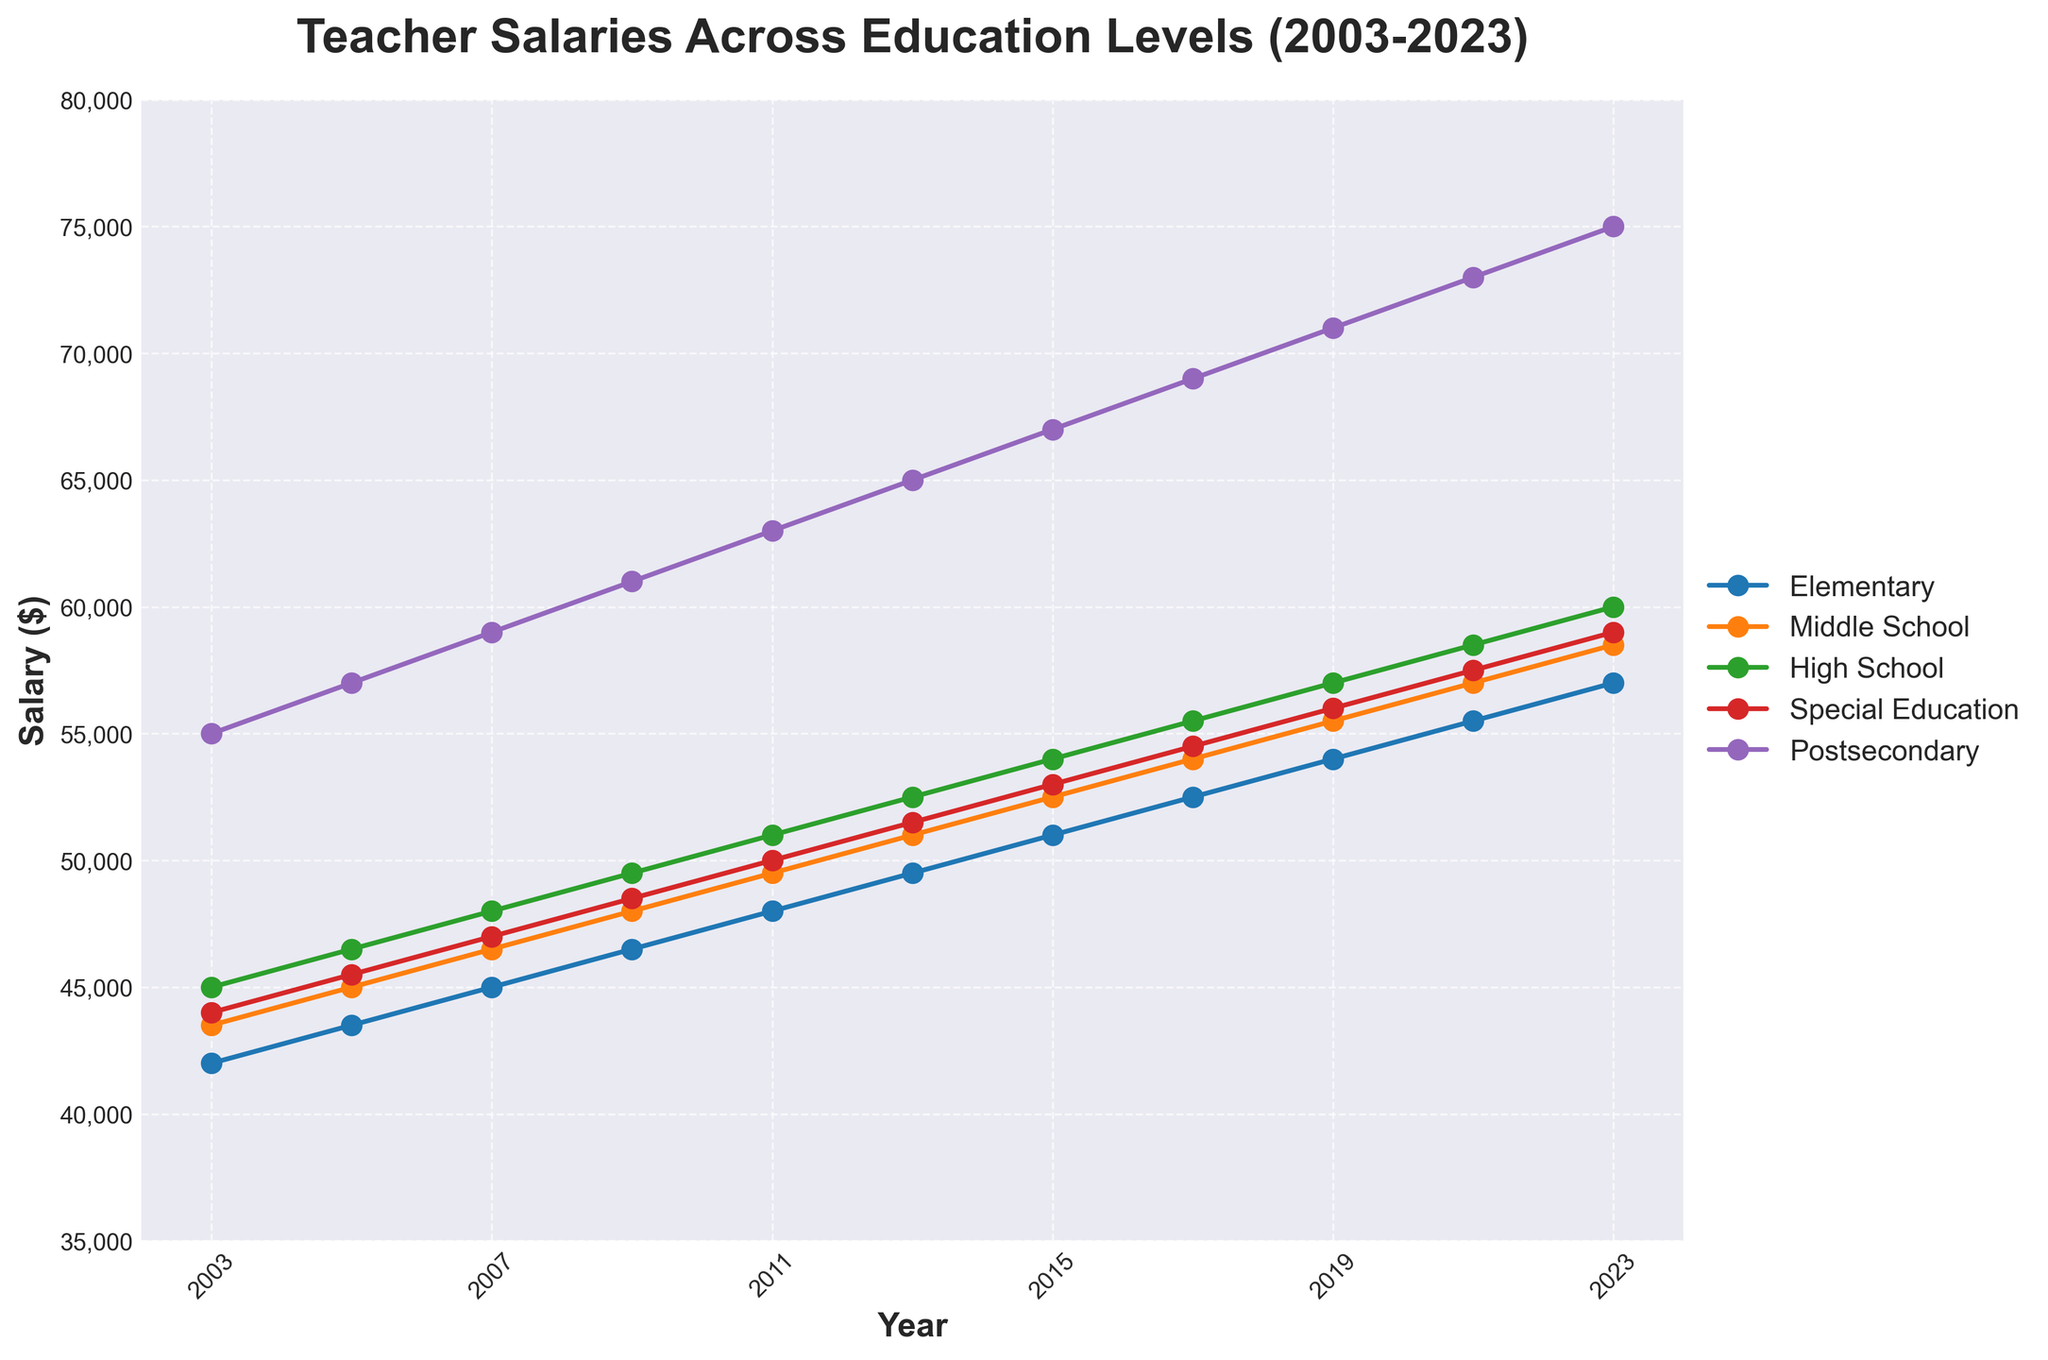What's the general trend of teacher salaries for Elementary teachers from 2003 to 2023? The figure shows a steady increase in salaries from 42,000 in 2003 to 57,000 in 2023.
Answer: An increasing trend Which education level has the highest salary in 2023? Refer to the far-right end of the plot and compare the salary lines. Postsecondary teachers have the highest salary at 75,000.
Answer: Postsecondary In 2011, how much more did High School teachers earn compared to Middle School teachers? Locate the salaries for 2011 for High School (51,000) and Middle School (49,500), then subtract the latter from the former: 51,000 - 49,500 = 1,500.
Answer: 1,500 What is the combined salary of Special Education teachers in 2009 and High School teachers in 2023? Locate the salary for Special Education teachers in 2009 (48,500) and High School teachers in 2023 (60,000), then add them together: 48,500 + 60,000 = 108,500.
Answer: 108,500 Which education level had the least growth in salary from 2003 to 2023? Calculate the difference for each level: Elementary (15,000), Middle School (15,000), High School (15,000), Special Education (15,000), Postsecondary (20,000). All except Postsecondary have the same growth. Given the requirement for a comparison question the concise answer focuses on these identical values.
Answer: Elementary, Middle School, High School, Special Education How did the salaries for Special Education teachers compare visually to Postsecondary teachers through the years? Visually, the line for Special Education is consistently below that of Postsecondary, indicating lower salaries. The Postsecondary salaries are always at the top of the figure.
Answer: Always lower What is the difference between the lowest and highest teacher salaries in 2015? Identify the lowest (Elementary, 51,000) and highest (Postsecondary, 67,000) salaries in 2015 and compute the difference: 67,000 - 51,000 = 16,000.
Answer: 16,000 By how much did the salary for Postsecondary teachers increase between 2011 and 2017? Locate the salaries for Postsecondary in 2011 (63,000) and 2017 (69,000), then subtract the former from the latter: 69,000 - 63,000 = 6,000.
Answer: 6,000 Which two education levels had the closest salaries in 2019? Locate the salaries in 2019: Elementary (54,000), Middle School (55,500), High School (57,000), Special Education (56,000), Postsecondary (71,000). The closest salaries are for Middle School and Special Education.
Answer: Middle School and Special Education What is the average salary for Elementary teachers over the entire period? Sum up the salaries for Elementary teachers over each year: 42,000 + 43,500 + 45,000 + 46,500 + 48,000 + 49,500 + 51,000 + 52,500 + 54,000 + 55,500 + 57,000 = 544,000. Then divide by the 11 data points: 544,000 / 11 ≈ 49,455.
Answer: 49,455 